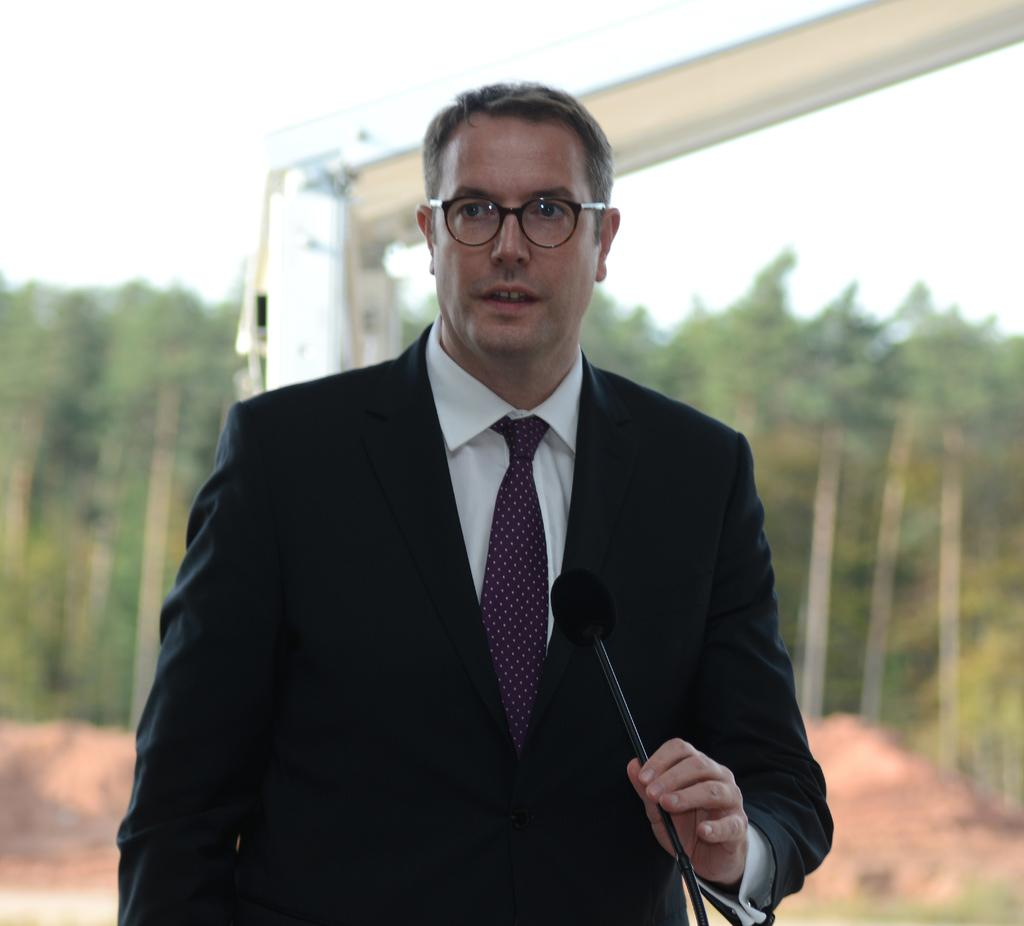What can be seen in the background of the image? There is a sky in the image. What type of vegetation is present in the image? There are trees in the image. What is the man in the image holding? The man is holding a microphone in the image. How many feet can be seen on the man's daughter in the image? There is no daughter present in the image, and therefore no feet can be seen. 